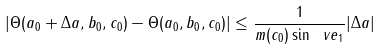Convert formula to latex. <formula><loc_0><loc_0><loc_500><loc_500>| \Theta ( a _ { 0 } + \Delta a , b _ { 0 } , c _ { 0 } ) - \Theta ( a _ { 0 } , b _ { 0 } , c _ { 0 } ) | \leq \frac { 1 } { m ( c _ { 0 } ) \sin \ v e _ { 1 } } | \Delta a |</formula> 